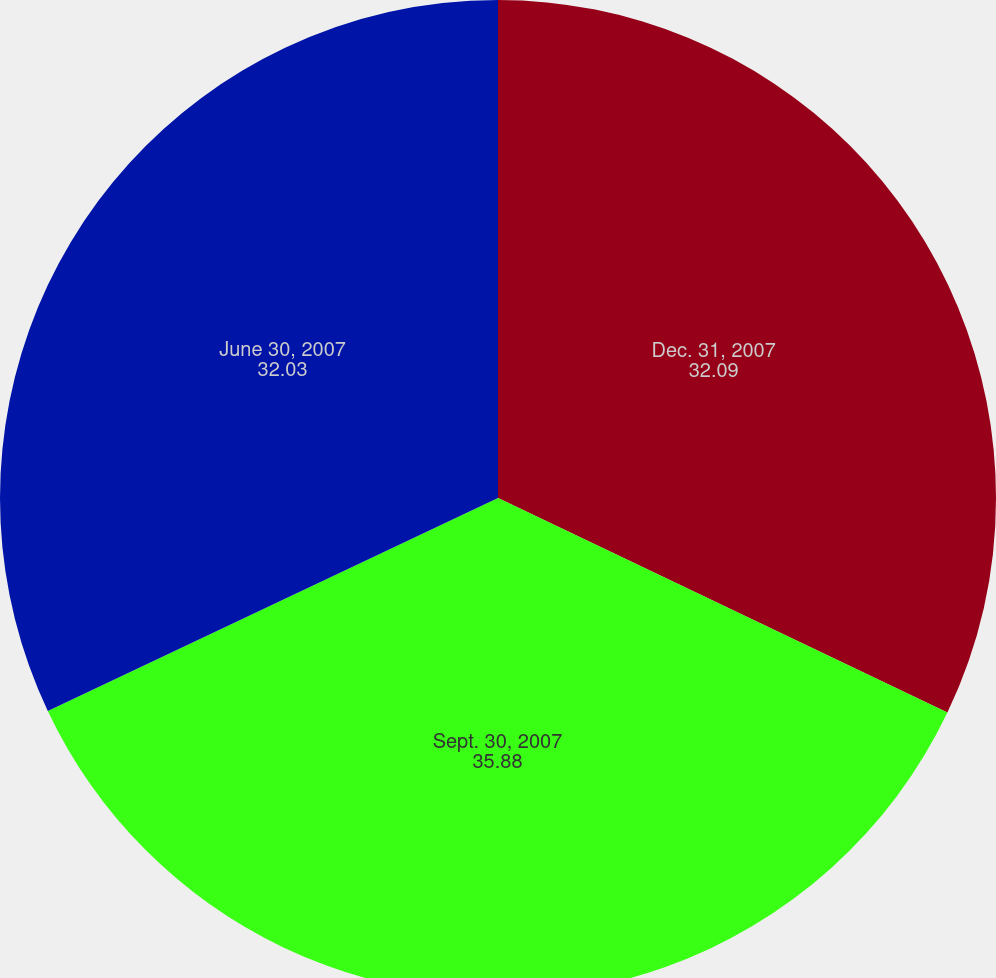<chart> <loc_0><loc_0><loc_500><loc_500><pie_chart><fcel>Dec. 31, 2007<fcel>Sept. 30, 2007<fcel>June 30, 2007<nl><fcel>32.09%<fcel>35.88%<fcel>32.03%<nl></chart> 